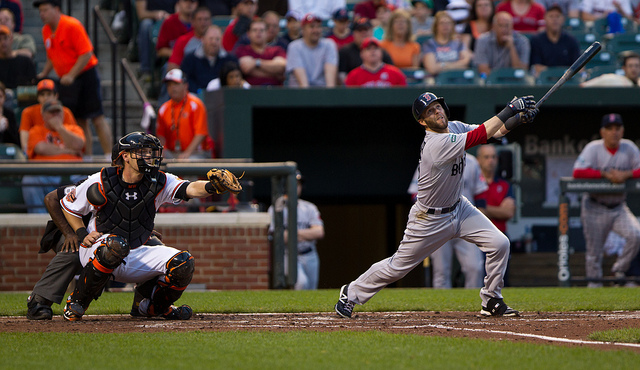Identify the text contained in this image. Bank H 